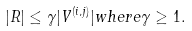<formula> <loc_0><loc_0><loc_500><loc_500>| R | \leq \gamma | V ^ { ( i , j ) } | w h e r e \gamma \geq 1 .</formula> 